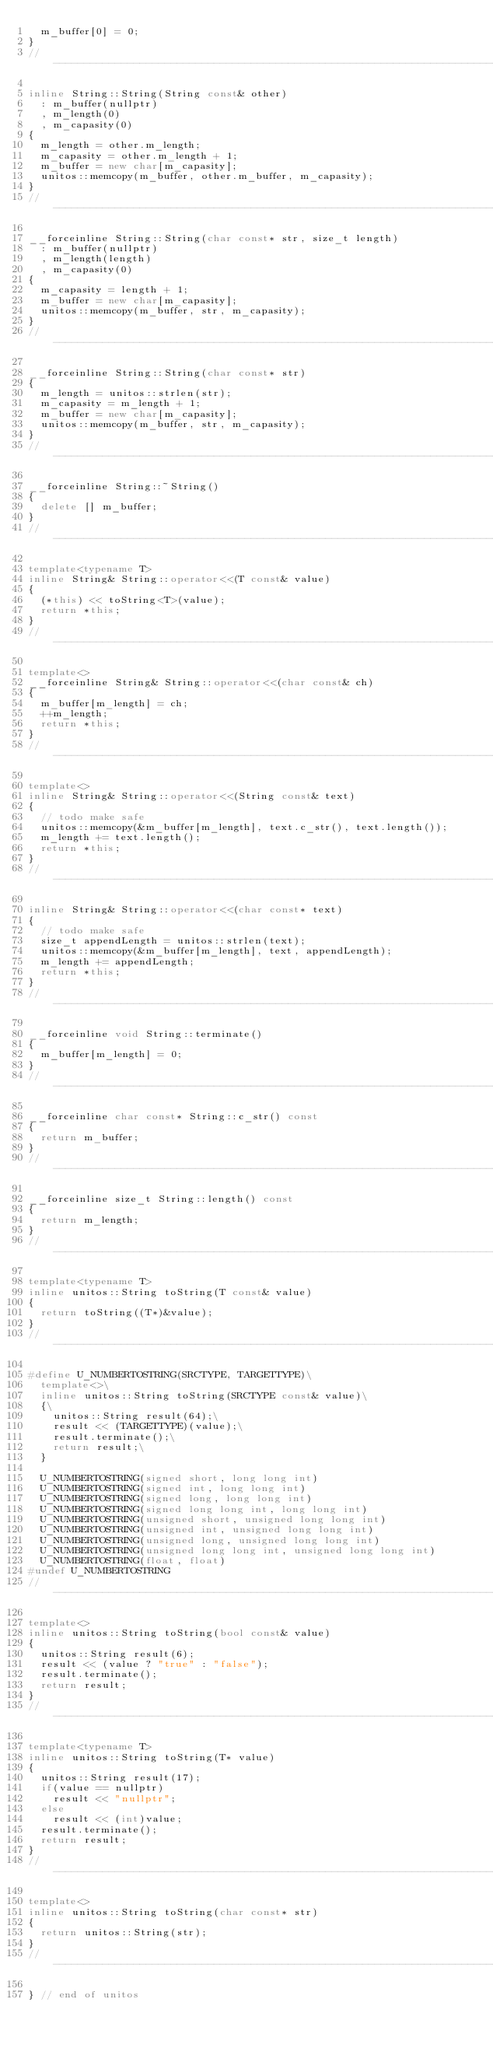<code> <loc_0><loc_0><loc_500><loc_500><_C++_>	m_buffer[0] = 0;
}
//----------------------------------------------------------------------------

inline String::String(String const& other)
	: m_buffer(nullptr)
	, m_length(0)
	, m_capasity(0)
{
	m_length = other.m_length;
	m_capasity = other.m_length + 1;
	m_buffer = new char[m_capasity];
	unitos::memcopy(m_buffer, other.m_buffer, m_capasity);
}
//----------------------------------------------------------------------------

__forceinline String::String(char const* str, size_t length)
	: m_buffer(nullptr)
	, m_length(length)
	, m_capasity(0)
{
	m_capasity = length + 1;
	m_buffer = new char[m_capasity];
	unitos::memcopy(m_buffer, str, m_capasity);
}
//----------------------------------------------------------------------------

__forceinline String::String(char const* str)
{
	m_length = unitos::strlen(str);
	m_capasity = m_length + 1;
	m_buffer = new char[m_capasity];
	unitos::memcopy(m_buffer, str, m_capasity);
}
//----------------------------------------------------------------------------

__forceinline String::~String()
{
	delete [] m_buffer;
}
//----------------------------------------------------------------------------

template<typename T>
inline String& String::operator<<(T const& value)
{
	(*this) << toString<T>(value);
	return *this;
}
//----------------------------------------------------------------------------

template<>
__forceinline String& String::operator<<(char const& ch)
{
	m_buffer[m_length] = ch;
	++m_length;
	return *this;
}
//----------------------------------------------------------------------------

template<>
inline String& String::operator<<(String const& text)
{
	// todo make safe
	unitos::memcopy(&m_buffer[m_length], text.c_str(), text.length());
	m_length += text.length();
	return *this;
}
//----------------------------------------------------------------------------

inline String& String::operator<<(char const* text)
{
	// todo make safe
	size_t appendLength = unitos::strlen(text);
	unitos::memcopy(&m_buffer[m_length], text, appendLength);
	m_length += appendLength;
	return *this;
}
//----------------------------------------------------------------------------

__forceinline void String::terminate()
{
	m_buffer[m_length] = 0;
}
//----------------------------------------------------------------------------

__forceinline char const* String::c_str() const
{
	return m_buffer;
}
//----------------------------------------------------------------------------

__forceinline size_t String::length() const
{
	return m_length;
}
//----------------------------------------------------------------------------

template<typename T>
inline unitos::String toString(T const& value)
{
	return toString((T*)&value);
}
//----------------------------------------------------------------------------

#define U_NUMBERTOSTRING(SRCTYPE, TARGETTYPE)\
	template<>\
	inline unitos::String toString(SRCTYPE const& value)\
	{\
		unitos::String result(64);\
		result << (TARGETTYPE)(value);\
		result.terminate();\
		return result;\
	}

	U_NUMBERTOSTRING(signed short, long long int)
	U_NUMBERTOSTRING(signed int, long long int)
	U_NUMBERTOSTRING(signed long, long long int)
	U_NUMBERTOSTRING(signed long long int, long long int)
	U_NUMBERTOSTRING(unsigned short, unsigned long long int)
	U_NUMBERTOSTRING(unsigned int, unsigned long long int)
	U_NUMBERTOSTRING(unsigned long, unsigned long long int)
	U_NUMBERTOSTRING(unsigned long long int, unsigned long long int)
	U_NUMBERTOSTRING(float, float)
#undef U_NUMBERTOSTRING
//----------------------------------------------------------------------------

template<>
inline unitos::String toString(bool const& value)
{
	unitos::String result(6);
	result << (value ? "true" : "false");
	result.terminate();
	return result;
}
//----------------------------------------------------------------------------

template<typename T>
inline unitos::String toString(T* value)
{
	unitos::String result(17);
	if(value == nullptr)
		result << "nullptr";
	else
		result << (int)value;
	result.terminate();
	return result;
}
//----------------------------------------------------------------------------

template<>
inline unitos::String toString(char const* str)
{
	return unitos::String(str);
}
//----------------------------------------------------------------------------

} // end of unitos
</code> 